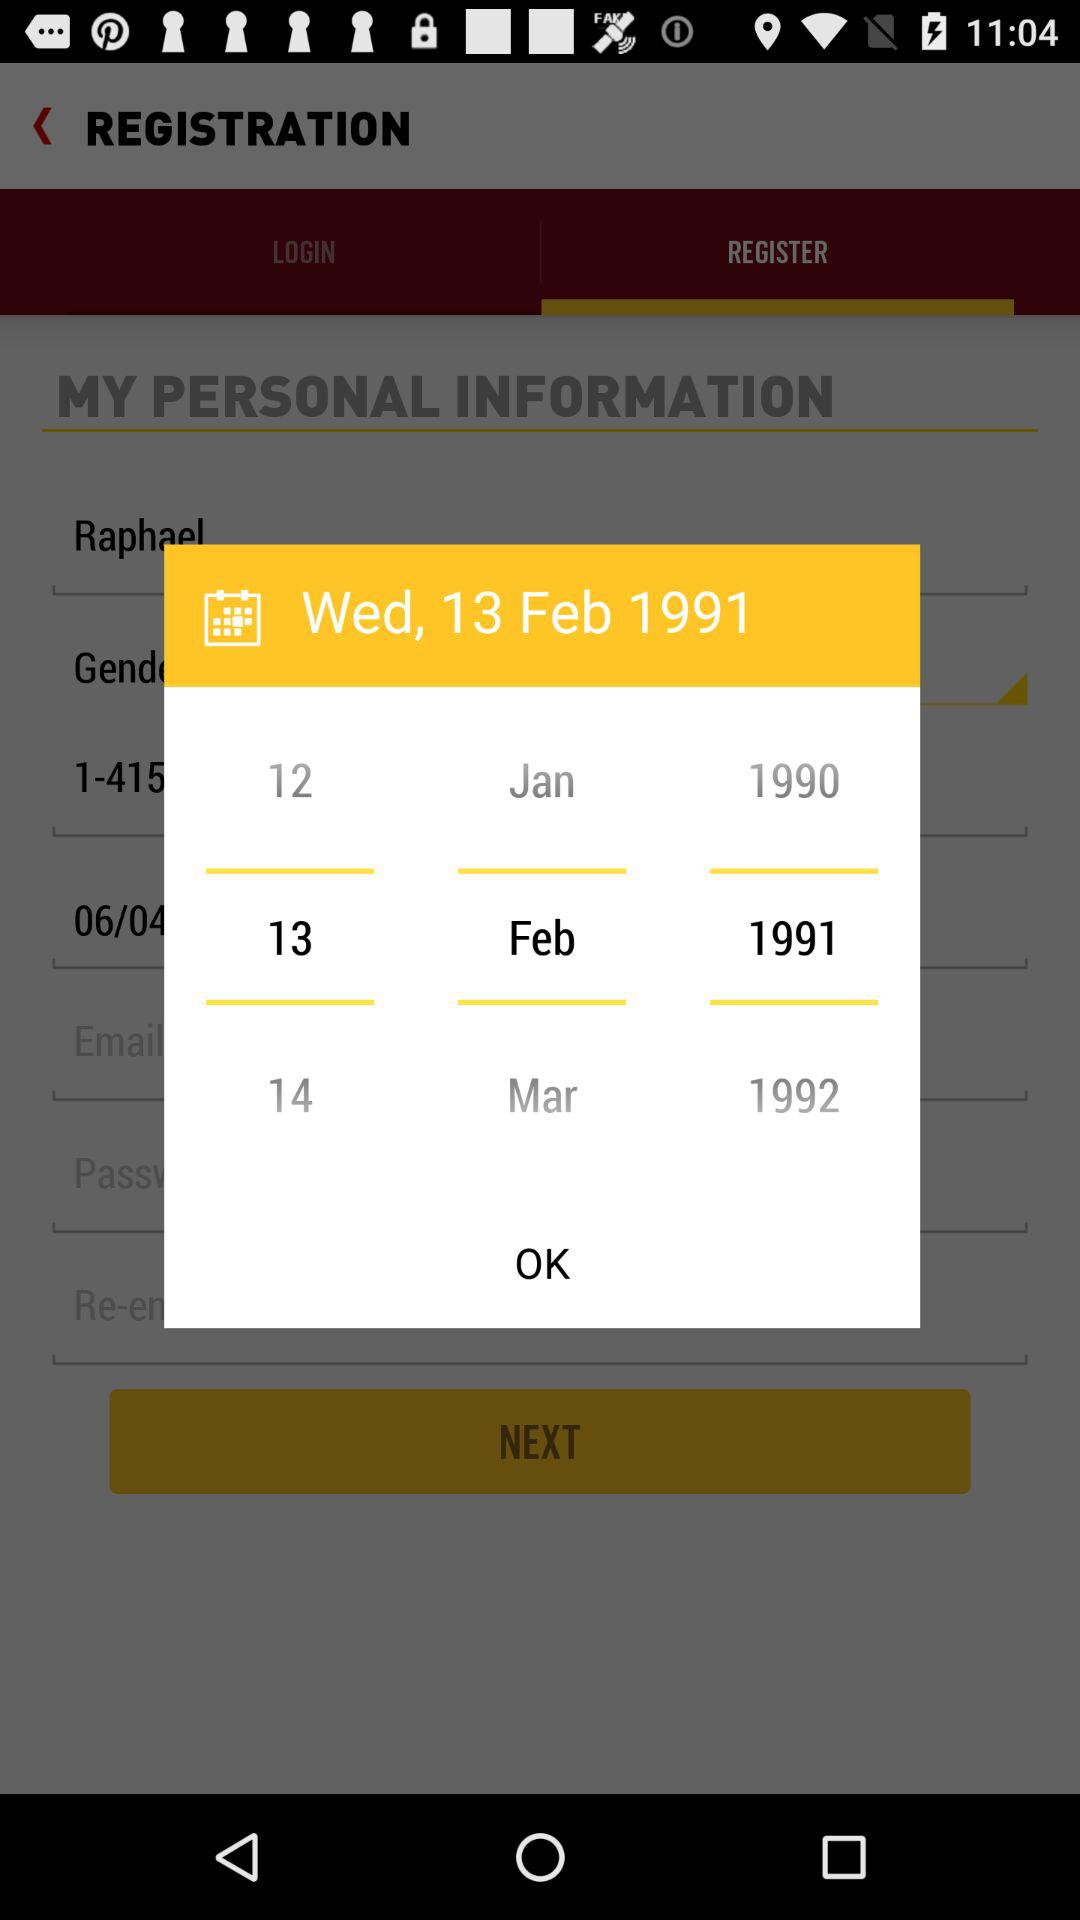Which day falls on February 13, 1991? The day is Wednesday. 